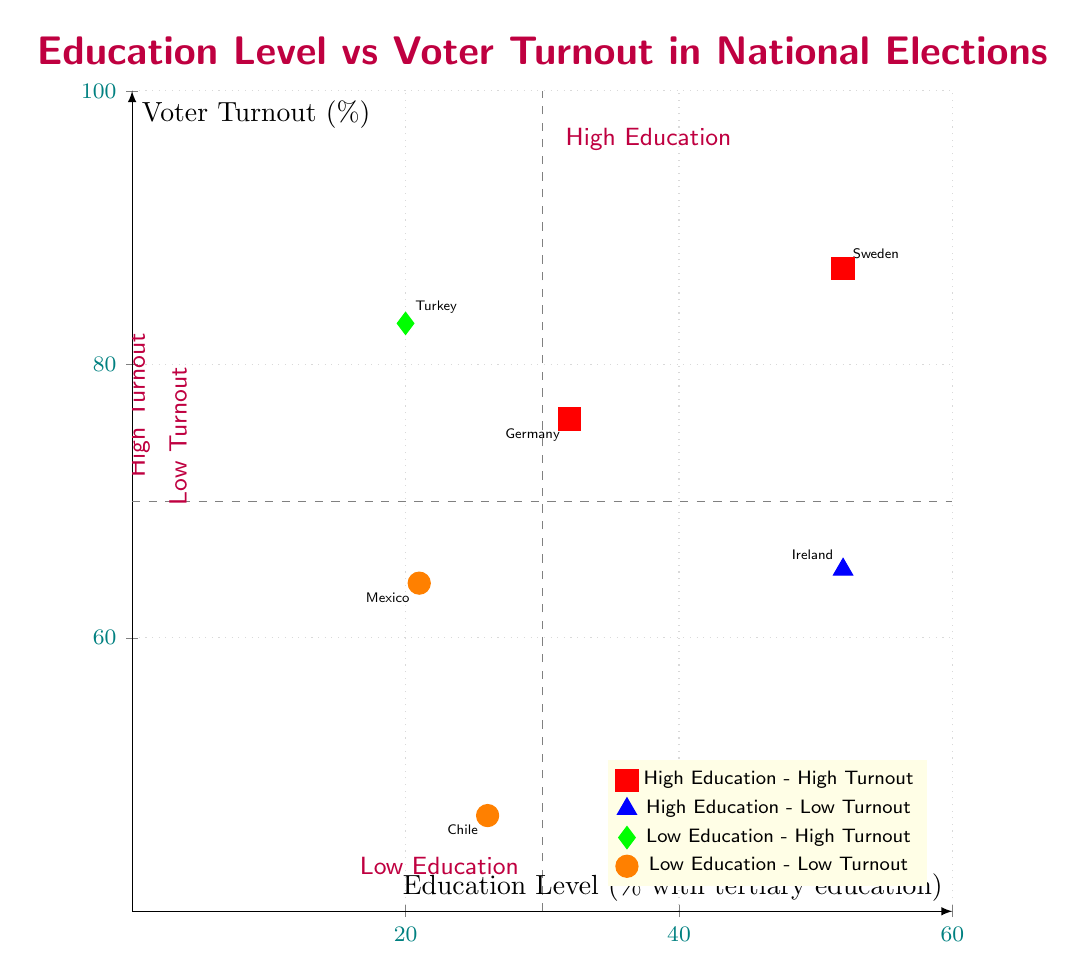What's the voter turnout percentage for Sweden? Sweden is located in the "High Education - High Voter Turnout" quadrant. There, the data shows that Sweden has a voter turnout percentage of 87%.
Answer: 87 Which country has the lowest voter turnout? The "Low Education - Low Voter Turnout" quadrant includes both Mexico and Chile, but among these, Chile has the lowest turnout at 47%.
Answer: Chile How many countries are in the "Low Education - High Voter Turnout" quadrant? This quadrant contains only one country, which is Turkey, indicating that it has a low education level but a relatively high voter turnout at 83%.
Answer: 1 What percent of the population in Ireland has tertiary education? Ireland is located in the "High Education - Low Voter Turnout" quadrant, where it is noted that 52% of the population has tertiary education.
Answer: 52 Which quadrant contains Germany? Germany falls within the "High Education - High Voter Turnout" quadrant, where it is indicated to have 32% of tertiary education and a voter turnout of 76%.
Answer: High Education - High Voter Turnout What is the education level percentage of Mexico? Mexico is located in the "Low Education - Low Voter Turnout" quadrant and has an education level of 21% with tertiary education.
Answer: 21 Which country among those with high education has a voter turnout lower than 70%? Among the countries in the "High Education - Low Voter Turnout" and "High Education - High Voter Turnout" quadrants, only Ireland meets this criterion with a voter turnout of 65%.
Answer: Ireland What is the relationship between education level and voter turnout in Turkey? Turkey, found in the "Low Education - High Voter Turnout" quadrant, suggests that despite having a low education level (20% with tertiary education), it achieves a high voter turnout of 83%.
Answer: Low Education - High Voter Turnout 